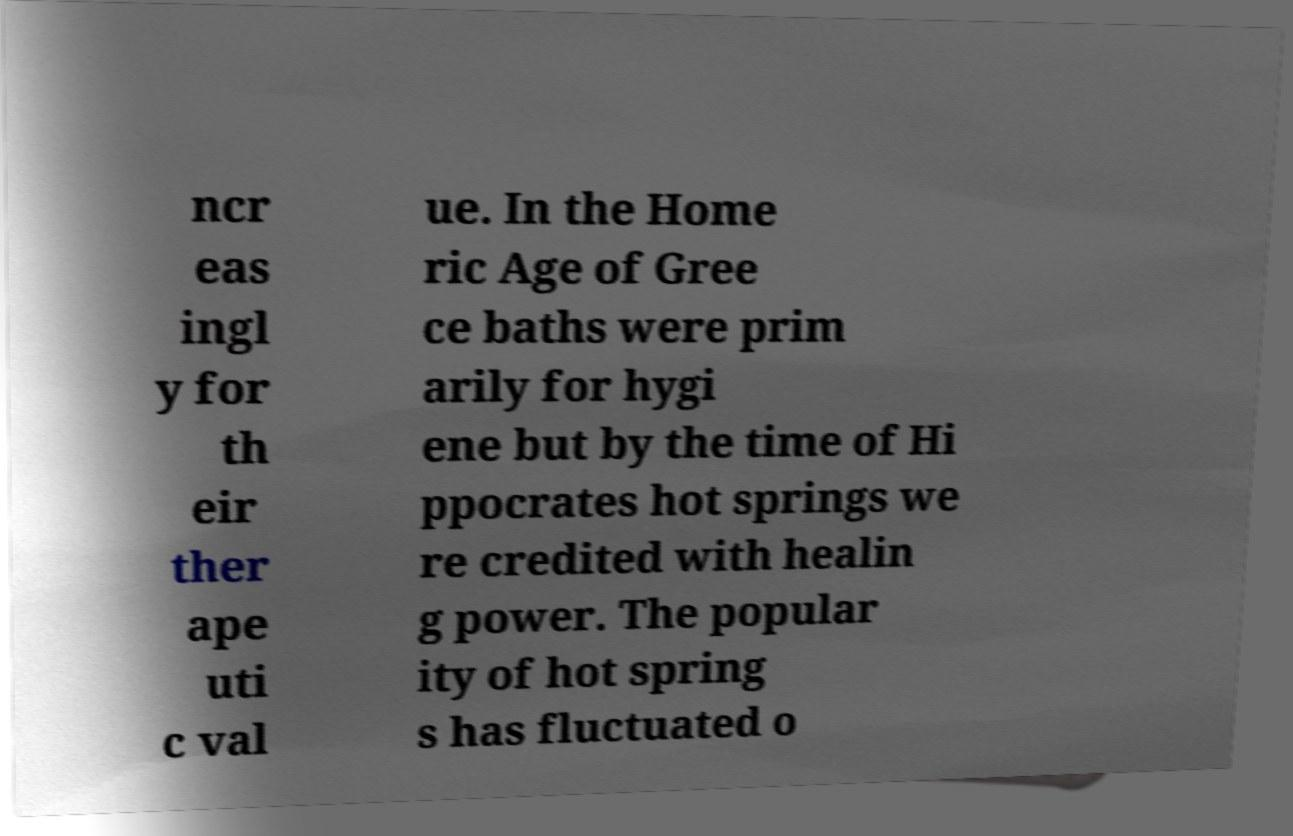Please identify and transcribe the text found in this image. ncr eas ingl y for th eir ther ape uti c val ue. In the Home ric Age of Gree ce baths were prim arily for hygi ene but by the time of Hi ppocrates hot springs we re credited with healin g power. The popular ity of hot spring s has fluctuated o 